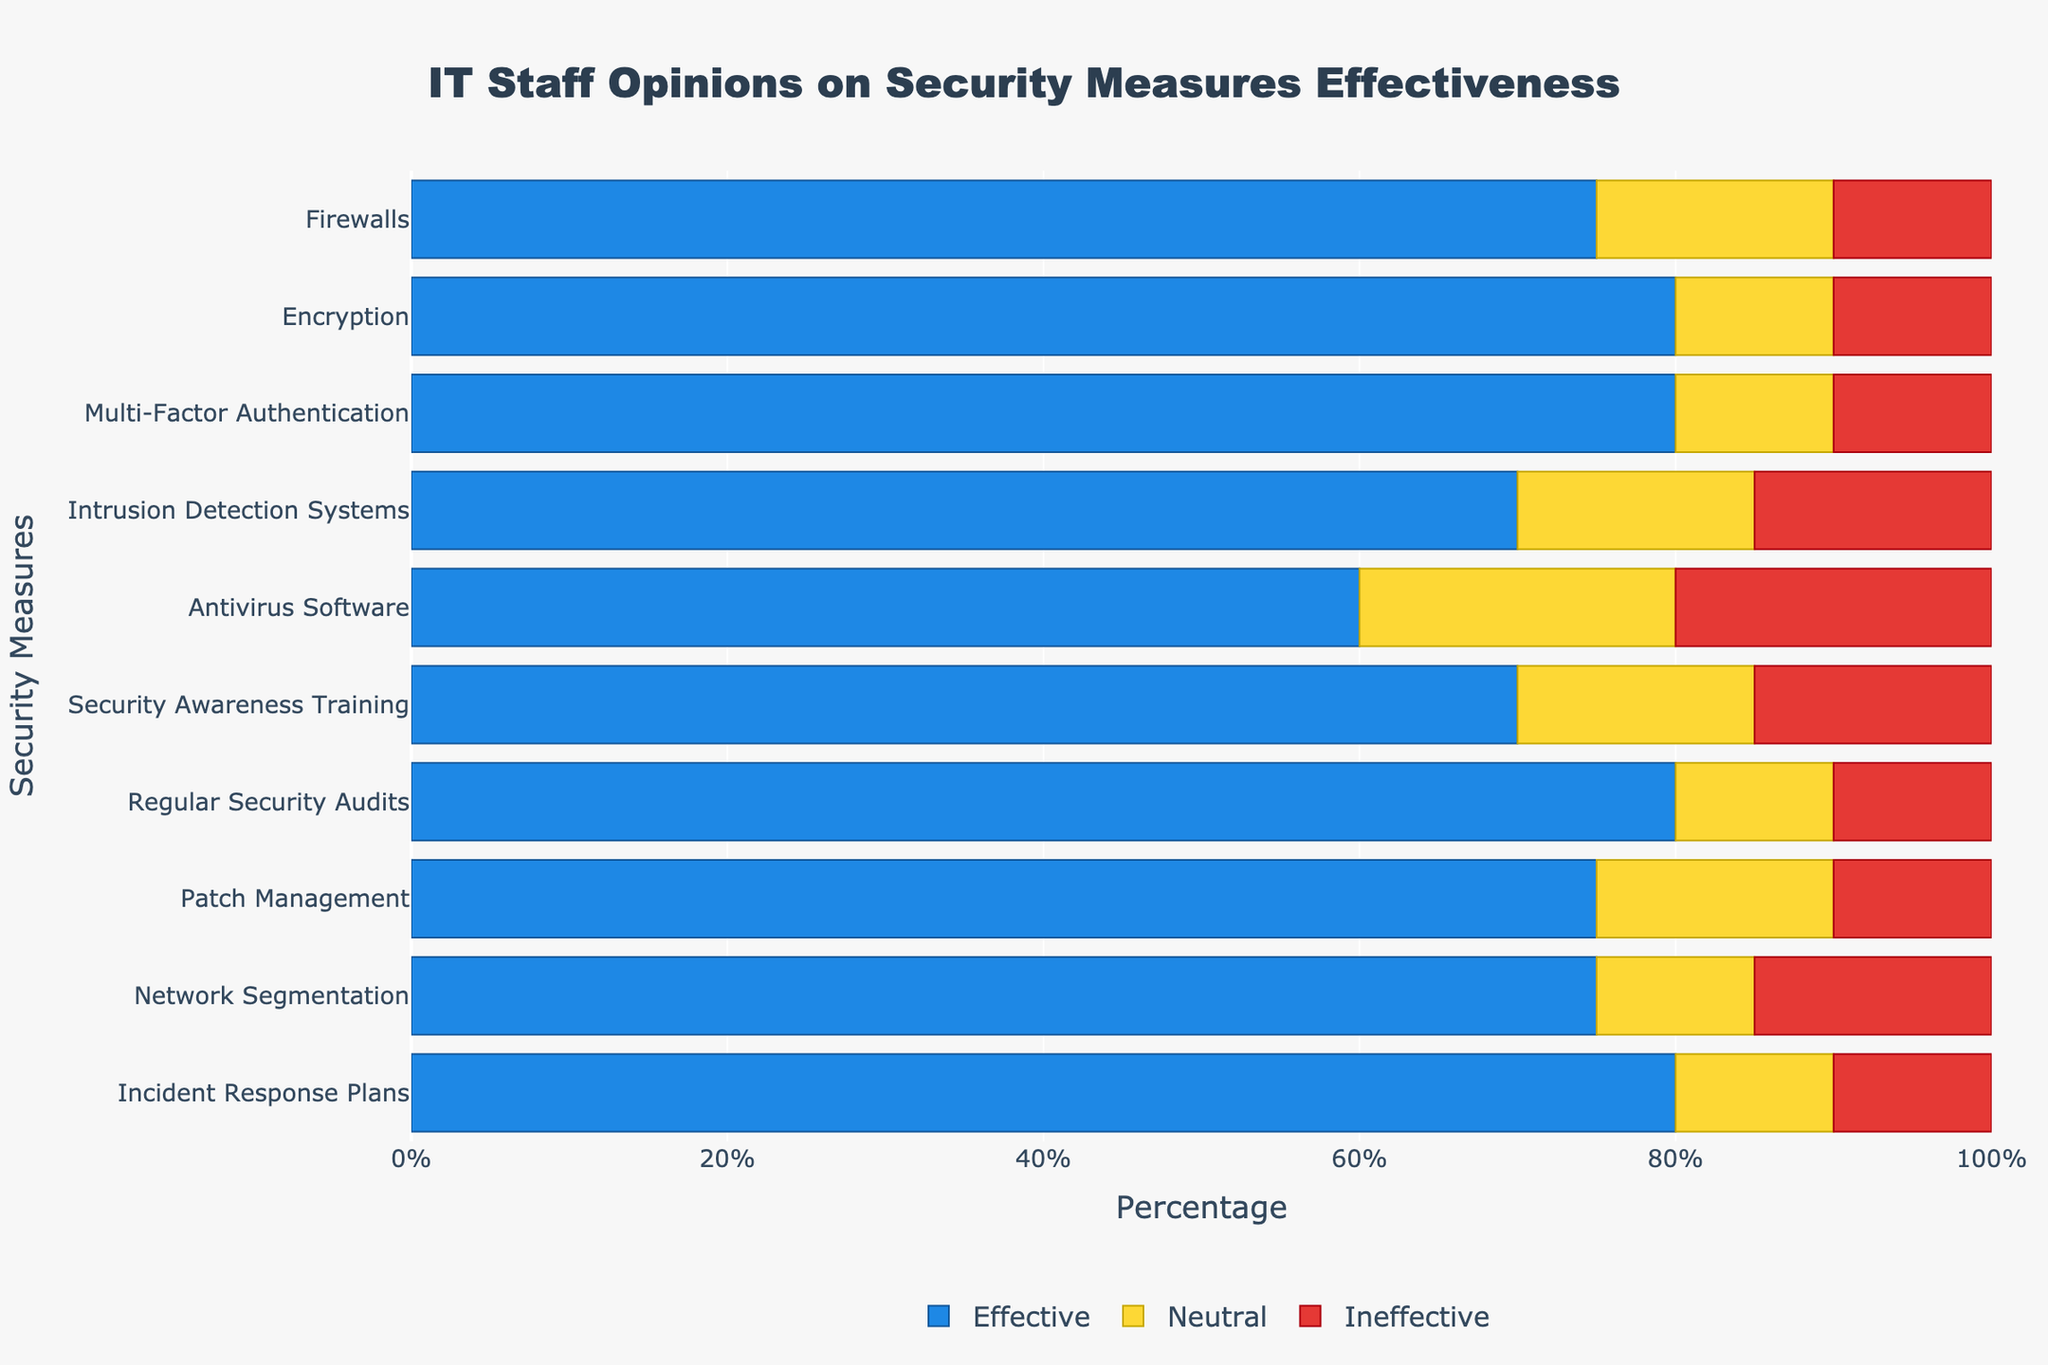What percentage of IT staff believes that Incident Response Plans are either Highly Effective or Somewhat Effective? To determine the percentage of IT staff who find Incident Response Plans effective, locate the values for Highly Effective (50%) and Somewhat Effective (30%). Adding these values gives 50% + 30% = 80%.
Answer: 80% Which security measure has the highest percentage of IT staff rating it as Highly Ineffective and what is that percentage? Identify the value in the 'Highly Ineffective' category that is the greatest. According to the data, Antivirus Software has the highest value at 10%.
Answer: Antivirus Software, 10% Compare the negativity (Somewhat Ineffective + Highly Ineffective) of Intrusion Detection Systems and Firewalls. Which one has more negative feedback and by how much? Calculate the total negative feedback for both measures. For Intrusion Detection Systems, the sum is 10% + 5% = 15%. For Firewalls, it is 5% + 5% = 10%. Intrusion Detection Systems have a higher negative feedback by 15% - 10% = 5%.
Answer: Intrusion Detection Systems, 5% What is the total neutral percentage for Network Segmentation, Security Awareness Training, and Regular Security Audits combined? Sum the neutral percentages for Network Segmentation (10%), Security Awareness Training (15%), and Regular Security Audits (10%). Adding these values, we get 10% + 15% + 10% = 35%.
Answer: 35% Which two security measures have the same percentage of IT staff rating them as Neutral, and what is this percentage? Identify the security measures with identical Neutral values. Both Encryption and Incident Response Plans have a neutral rating of 10%.
Answer: Encryption and Incident Response Plans, 10% Among Firewalls, Encryption, and Multi-Factor Authentication, which one has the highest total percentage of IT staff considering these measures effective (Highly Effective + Somewhat Effective)? Calculate the effective percentages for each:
- Firewalls: 35% + 40% = 75%
- Encryption: 45% + 35% = 80%
- Multi-Factor Authentication: 50% + 30% = 80%
Both Encryption and Multi-Factor Authentication have the highest effective percentages at 80%.
Answer: Encryption and Multi-Factor Authentication, 80% Which security measure has the lowest percentage of IT staff rating it as Somewhat Effective and what is the percentage? Identify the lowest value in the 'Somewhat Effective' category. For Antivirus Software, the percentage is 35%, which is the lowest among the measures.
Answer: Antivirus Software, 35% 